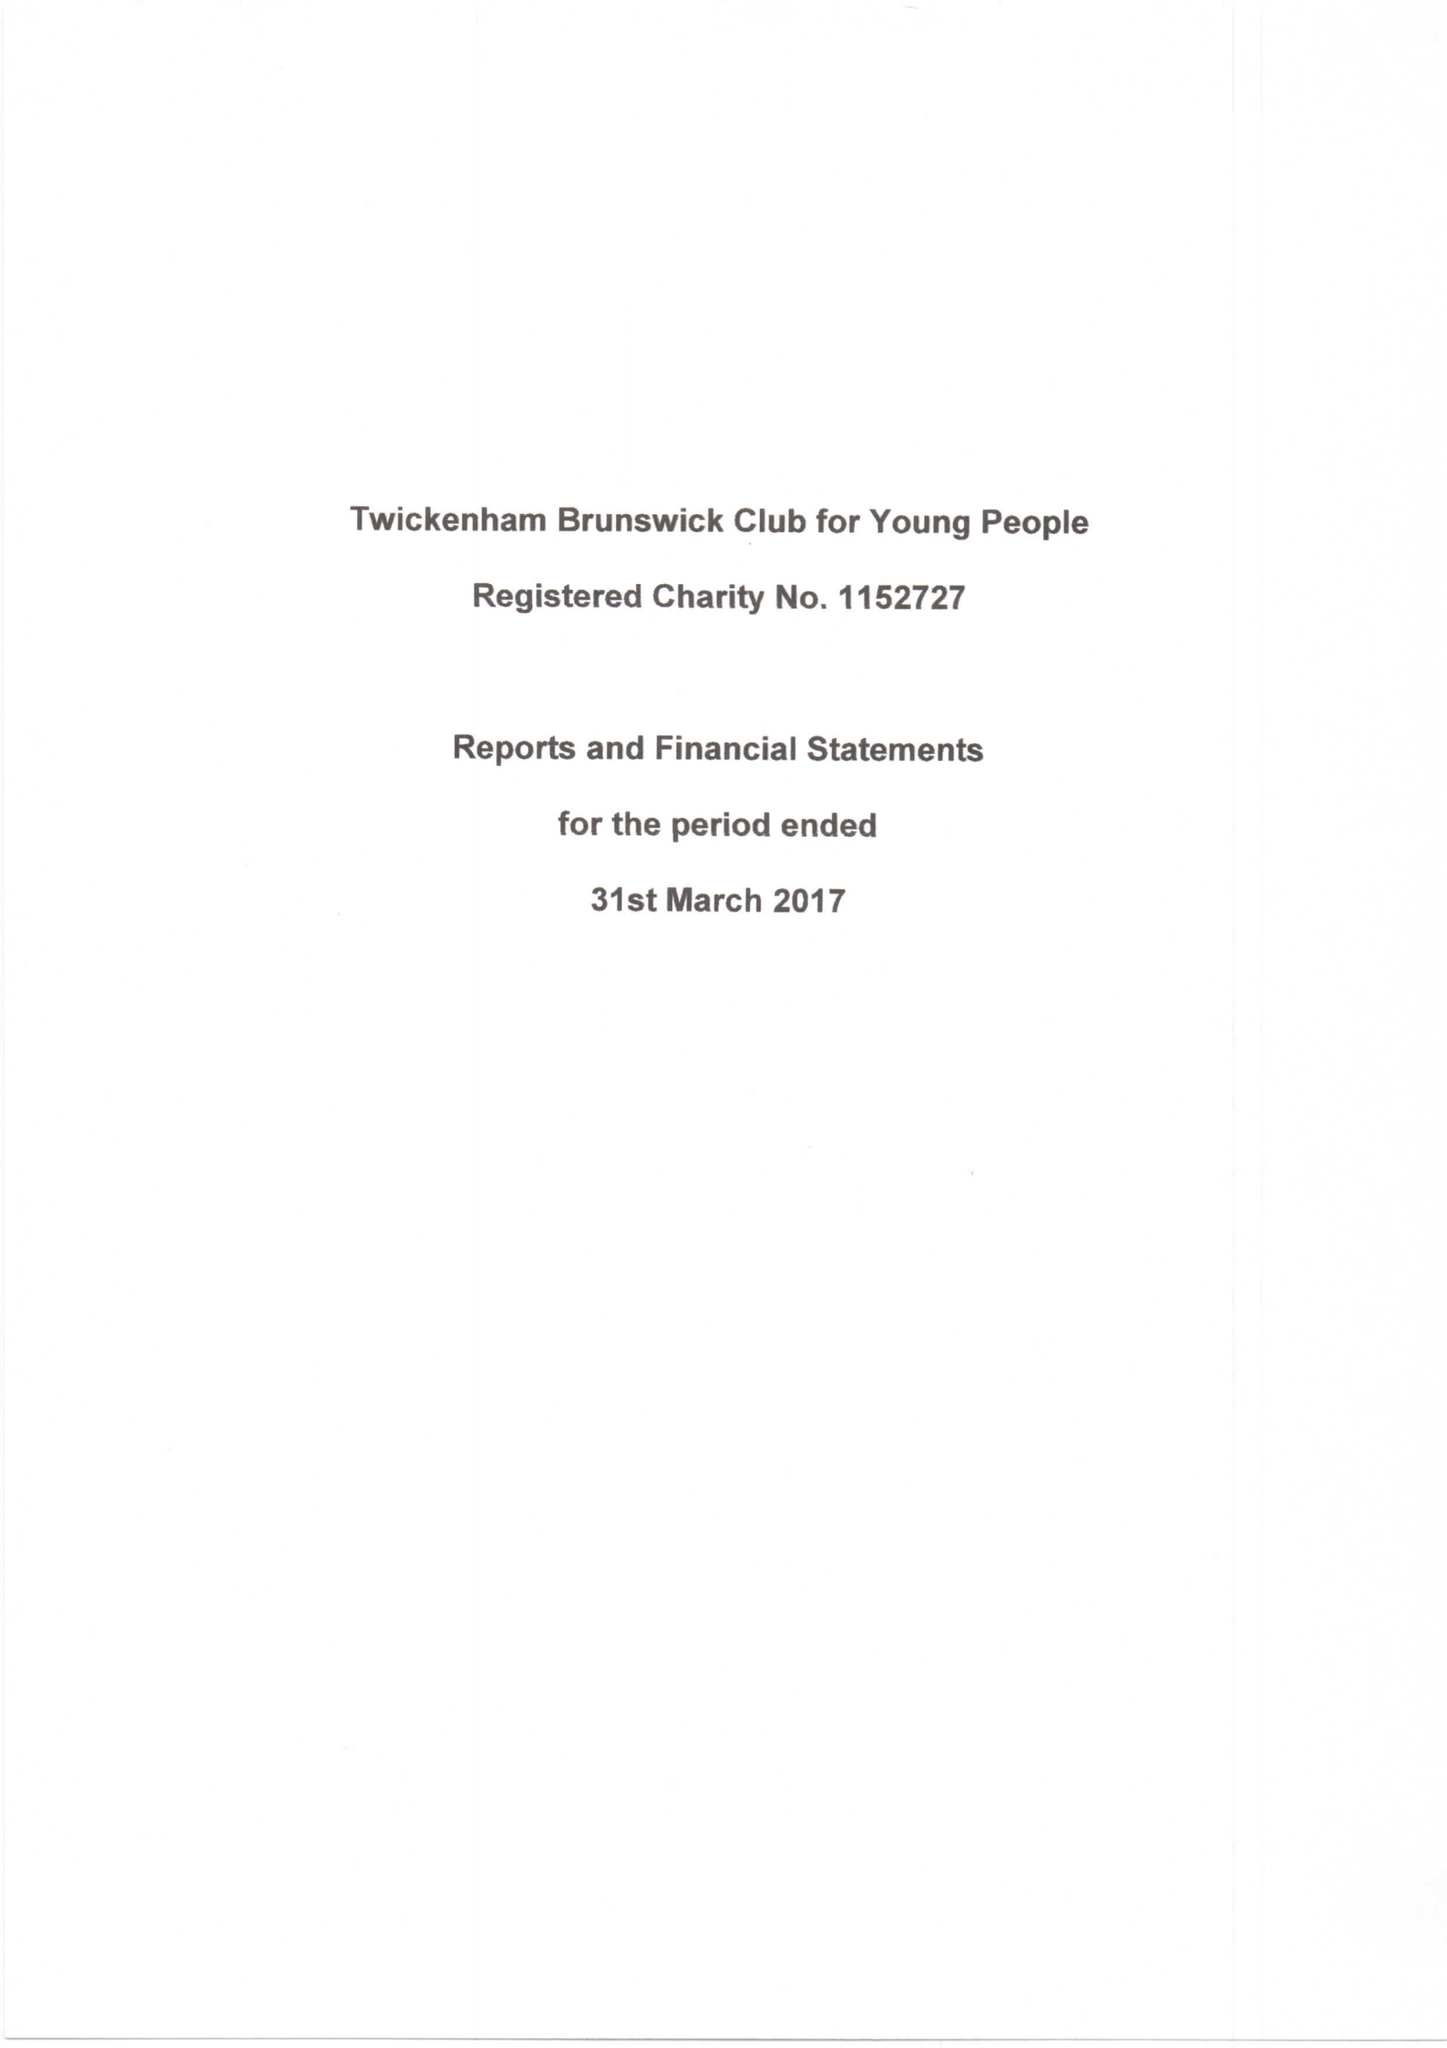What is the value for the address__postcode?
Answer the question using a single word or phrase. TW2 5LN 